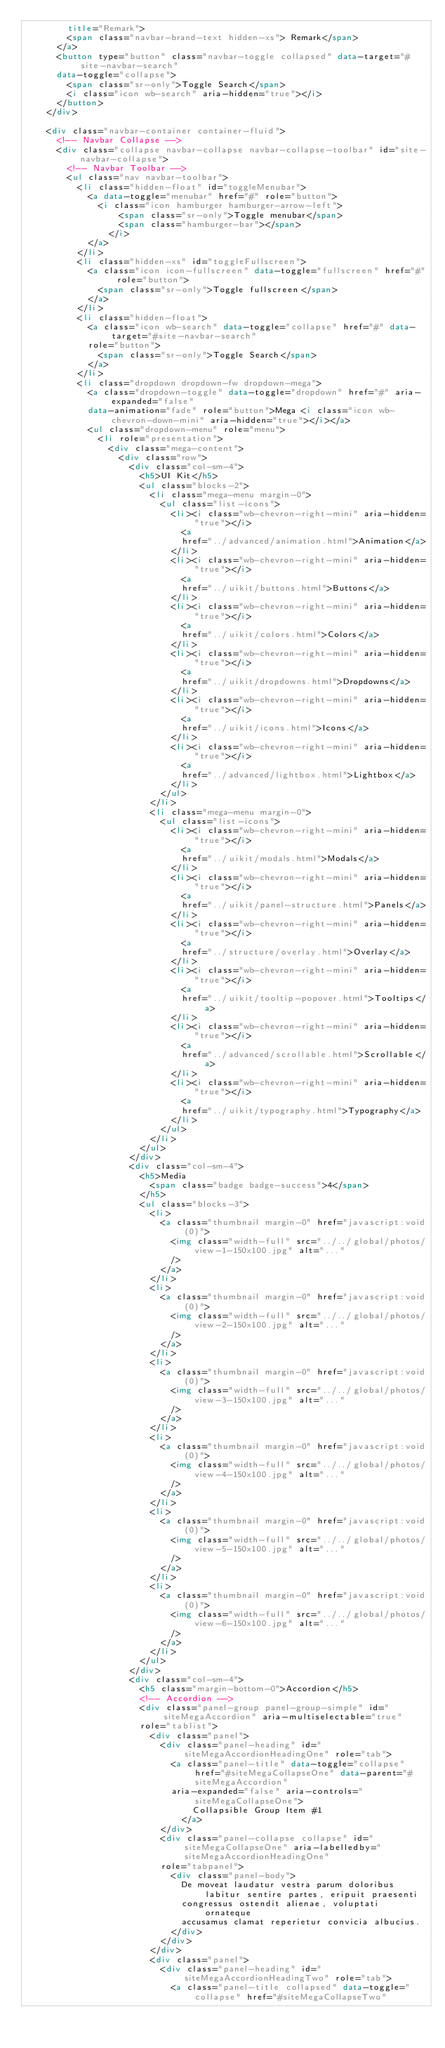Convert code to text. <code><loc_0><loc_0><loc_500><loc_500><_HTML_>        title="Remark">
        <span class="navbar-brand-text hidden-xs"> Remark</span>
      </a>
      <button type="button" class="navbar-toggle collapsed" data-target="#site-navbar-search"
      data-toggle="collapse">
        <span class="sr-only">Toggle Search</span>
        <i class="icon wb-search" aria-hidden="true"></i>
      </button>
    </div>

    <div class="navbar-container container-fluid">
      <!-- Navbar Collapse -->
      <div class="collapse navbar-collapse navbar-collapse-toolbar" id="site-navbar-collapse">
        <!-- Navbar Toolbar -->
        <ul class="nav navbar-toolbar">
          <li class="hidden-float" id="toggleMenubar">
            <a data-toggle="menubar" href="#" role="button">
              <i class="icon hamburger hamburger-arrow-left">
                  <span class="sr-only">Toggle menubar</span>
                  <span class="hamburger-bar"></span>
                </i>
            </a>
          </li>
          <li class="hidden-xs" id="toggleFullscreen">
            <a class="icon icon-fullscreen" data-toggle="fullscreen" href="#" role="button">
              <span class="sr-only">Toggle fullscreen</span>
            </a>
          </li>
          <li class="hidden-float">
            <a class="icon wb-search" data-toggle="collapse" href="#" data-target="#site-navbar-search"
            role="button">
              <span class="sr-only">Toggle Search</span>
            </a>
          </li>
          <li class="dropdown dropdown-fw dropdown-mega">
            <a class="dropdown-toggle" data-toggle="dropdown" href="#" aria-expanded="false"
            data-animation="fade" role="button">Mega <i class="icon wb-chevron-down-mini" aria-hidden="true"></i></a>
            <ul class="dropdown-menu" role="menu">
              <li role="presentation">
                <div class="mega-content">
                  <div class="row">
                    <div class="col-sm-4">
                      <h5>UI Kit</h5>
                      <ul class="blocks-2">
                        <li class="mega-menu margin-0">
                          <ul class="list-icons">
                            <li><i class="wb-chevron-right-mini" aria-hidden="true"></i>
                              <a
                              href="../advanced/animation.html">Animation</a>
                            </li>
                            <li><i class="wb-chevron-right-mini" aria-hidden="true"></i>
                              <a
                              href="../uikit/buttons.html">Buttons</a>
                            </li>
                            <li><i class="wb-chevron-right-mini" aria-hidden="true"></i>
                              <a
                              href="../uikit/colors.html">Colors</a>
                            </li>
                            <li><i class="wb-chevron-right-mini" aria-hidden="true"></i>
                              <a
                              href="../uikit/dropdowns.html">Dropdowns</a>
                            </li>
                            <li><i class="wb-chevron-right-mini" aria-hidden="true"></i>
                              <a
                              href="../uikit/icons.html">Icons</a>
                            </li>
                            <li><i class="wb-chevron-right-mini" aria-hidden="true"></i>
                              <a
                              href="../advanced/lightbox.html">Lightbox</a>
                            </li>
                          </ul>
                        </li>
                        <li class="mega-menu margin-0">
                          <ul class="list-icons">
                            <li><i class="wb-chevron-right-mini" aria-hidden="true"></i>
                              <a
                              href="../uikit/modals.html">Modals</a>
                            </li>
                            <li><i class="wb-chevron-right-mini" aria-hidden="true"></i>
                              <a
                              href="../uikit/panel-structure.html">Panels</a>
                            </li>
                            <li><i class="wb-chevron-right-mini" aria-hidden="true"></i>
                              <a
                              href="../structure/overlay.html">Overlay</a>
                            </li>
                            <li><i class="wb-chevron-right-mini" aria-hidden="true"></i>
                              <a
                              href="../uikit/tooltip-popover.html">Tooltips</a>
                            </li>
                            <li><i class="wb-chevron-right-mini" aria-hidden="true"></i>
                              <a
                              href="../advanced/scrollable.html">Scrollable</a>
                            </li>
                            <li><i class="wb-chevron-right-mini" aria-hidden="true"></i>
                              <a
                              href="../uikit/typography.html">Typography</a>
                            </li>
                          </ul>
                        </li>
                      </ul>
                    </div>
                    <div class="col-sm-4">
                      <h5>Media
                        <span class="badge badge-success">4</span>
                      </h5>
                      <ul class="blocks-3">
                        <li>
                          <a class="thumbnail margin-0" href="javascript:void(0)">
                            <img class="width-full" src="../../global/photos/view-1-150x100.jpg" alt="..."
                            />
                          </a>
                        </li>
                        <li>
                          <a class="thumbnail margin-0" href="javascript:void(0)">
                            <img class="width-full" src="../../global/photos/view-2-150x100.jpg" alt="..."
                            />
                          </a>
                        </li>
                        <li>
                          <a class="thumbnail margin-0" href="javascript:void(0)">
                            <img class="width-full" src="../../global/photos/view-3-150x100.jpg" alt="..."
                            />
                          </a>
                        </li>
                        <li>
                          <a class="thumbnail margin-0" href="javascript:void(0)">
                            <img class="width-full" src="../../global/photos/view-4-150x100.jpg" alt="..."
                            />
                          </a>
                        </li>
                        <li>
                          <a class="thumbnail margin-0" href="javascript:void(0)">
                            <img class="width-full" src="../../global/photos/view-5-150x100.jpg" alt="..."
                            />
                          </a>
                        </li>
                        <li>
                          <a class="thumbnail margin-0" href="javascript:void(0)">
                            <img class="width-full" src="../../global/photos/view-6-150x100.jpg" alt="..."
                            />
                          </a>
                        </li>
                      </ul>
                    </div>
                    <div class="col-sm-4">
                      <h5 class="margin-bottom-0">Accordion</h5>
                      <!-- Accordion -->
                      <div class="panel-group panel-group-simple" id="siteMegaAccordion" aria-multiselectable="true"
                      role="tablist">
                        <div class="panel">
                          <div class="panel-heading" id="siteMegaAccordionHeadingOne" role="tab">
                            <a class="panel-title" data-toggle="collapse" href="#siteMegaCollapseOne" data-parent="#siteMegaAccordion"
                            aria-expanded="false" aria-controls="siteMegaCollapseOne">
                                Collapsible Group Item #1
                              </a>
                          </div>
                          <div class="panel-collapse collapse" id="siteMegaCollapseOne" aria-labelledby="siteMegaAccordionHeadingOne"
                          role="tabpanel">
                            <div class="panel-body">
                              De moveat laudatur vestra parum doloribus labitur sentire partes, eripuit praesenti
                              congressus ostendit alienae, voluptati ornateque
                              accusamus clamat reperietur convicia albucius.
                            </div>
                          </div>
                        </div>
                        <div class="panel">
                          <div class="panel-heading" id="siteMegaAccordionHeadingTwo" role="tab">
                            <a class="panel-title collapsed" data-toggle="collapse" href="#siteMegaCollapseTwo"</code> 